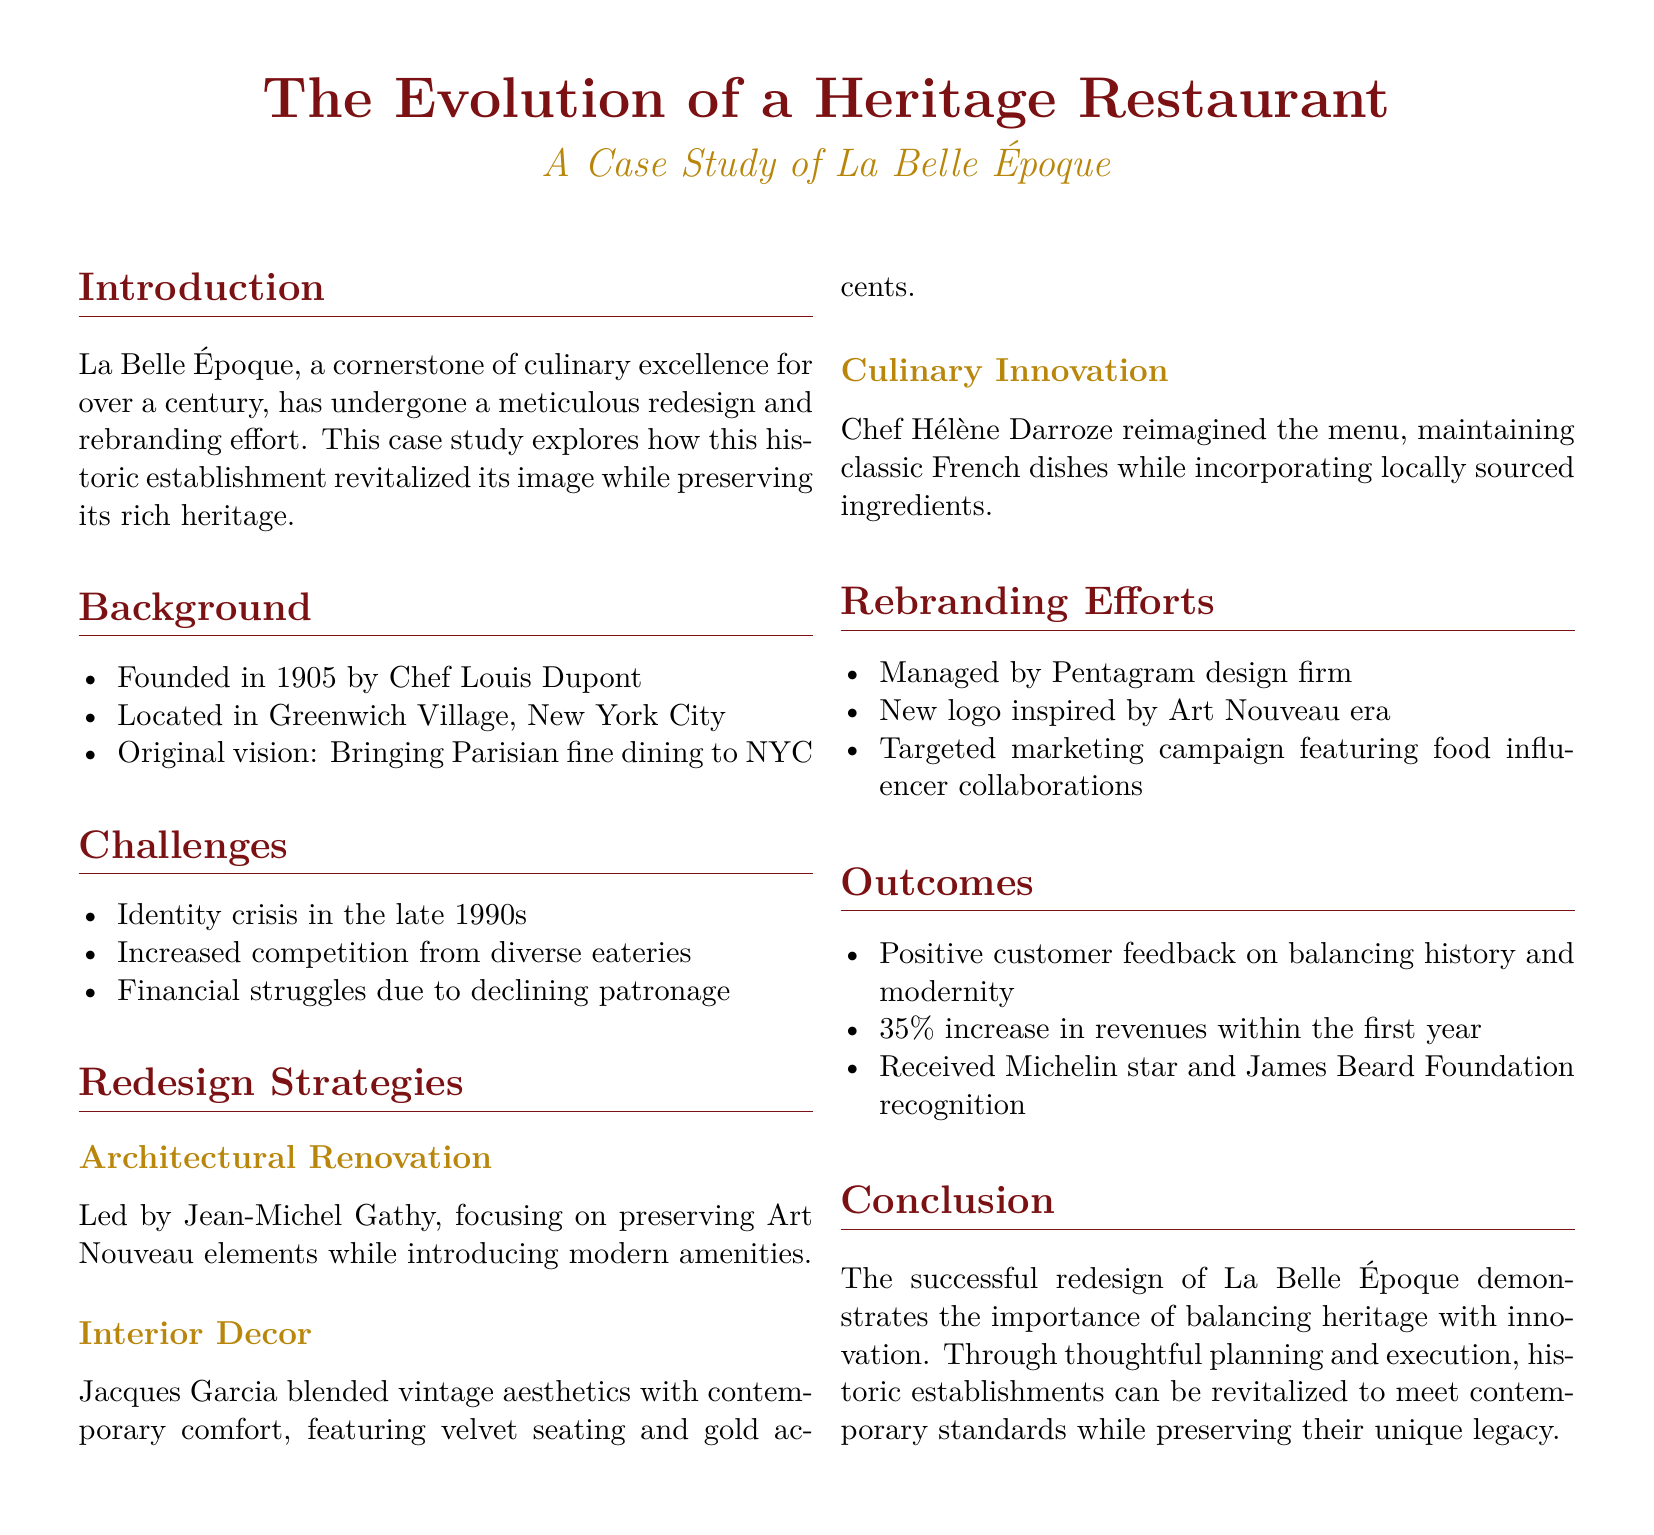What year was La Belle Époque founded? The founding year is stated in the background section of the document.
Answer: 1905 Who was the original founder of La Belle Époque? The document specifies the founder's name in the background section.
Answer: Chef Louis Dupont What city is La Belle Époque located in? The location is mentioned in the background section.
Answer: New York City What was a key challenge for La Belle Époque in the late 1990s? The challenges section includes specific challenges faced during that time period.
Answer: Identity crisis Who led the architectural renovation of La Belle Époque? The document attributes the leadership of the renovation to a specific person.
Answer: Jean-Michel Gathy What percentage increase in revenues did La Belle Époque experience within the first year after redesign? This information is provided under the outcomes section.
Answer: 35% Which design firm managed the rebranding effort? The rebranding efforts section lists the design firm responsible for the project.
Answer: Pentagram What culinary innovation did Chef Hélène Darroze introduce? The redesign strategies section mentions the approach Chef Hélène Darroze took regarding the menu.
Answer: Locally sourced ingredients What type of recognition did La Belle Époque receive after its redesign? The outcomes section speaks about the kinds of recognition achieved post-redesign.
Answer: Michelin star and James Beard Foundation recognition 